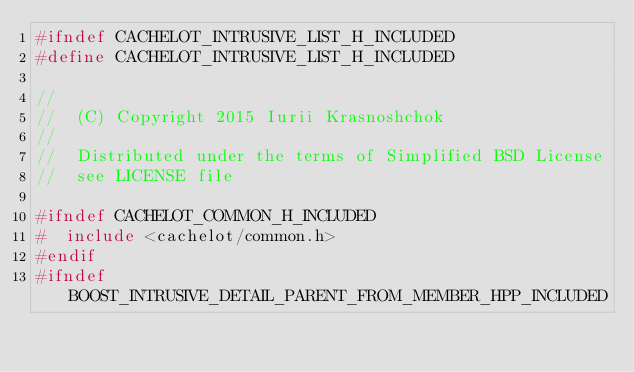<code> <loc_0><loc_0><loc_500><loc_500><_C_>#ifndef CACHELOT_INTRUSIVE_LIST_H_INCLUDED
#define CACHELOT_INTRUSIVE_LIST_H_INCLUDED

//
//  (C) Copyright 2015 Iurii Krasnoshchok
//
//  Distributed under the terms of Simplified BSD License
//  see LICENSE file

#ifndef CACHELOT_COMMON_H_INCLUDED
#  include <cachelot/common.h>
#endif
#ifndef BOOST_INTRUSIVE_DETAIL_PARENT_FROM_MEMBER_HPP_INCLUDED</code> 